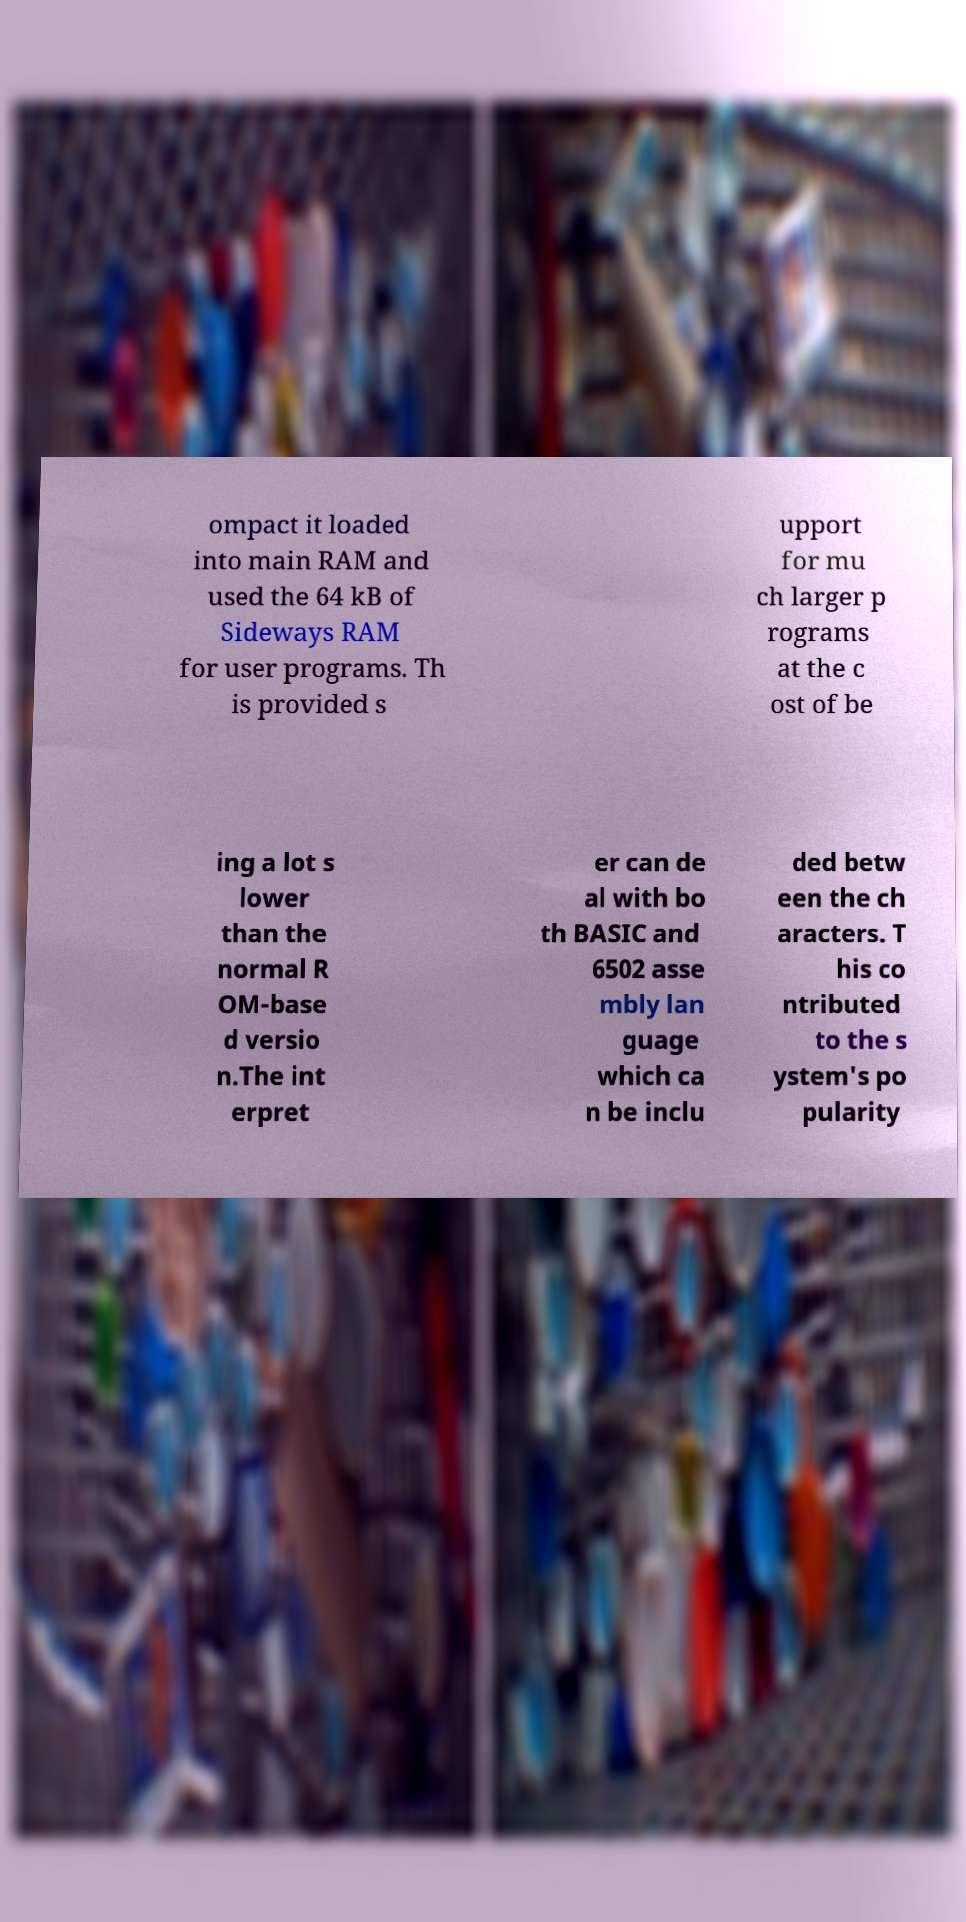Please identify and transcribe the text found in this image. ompact it loaded into main RAM and used the 64 kB of Sideways RAM for user programs. Th is provided s upport for mu ch larger p rograms at the c ost of be ing a lot s lower than the normal R OM-base d versio n.The int erpret er can de al with bo th BASIC and 6502 asse mbly lan guage which ca n be inclu ded betw een the ch aracters. T his co ntributed to the s ystem's po pularity 